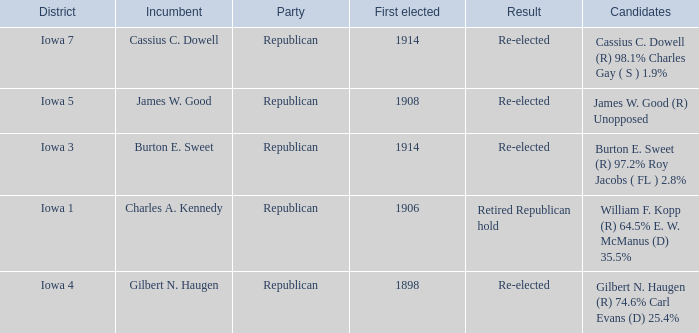What political party for burton e. sweet? Republican. 